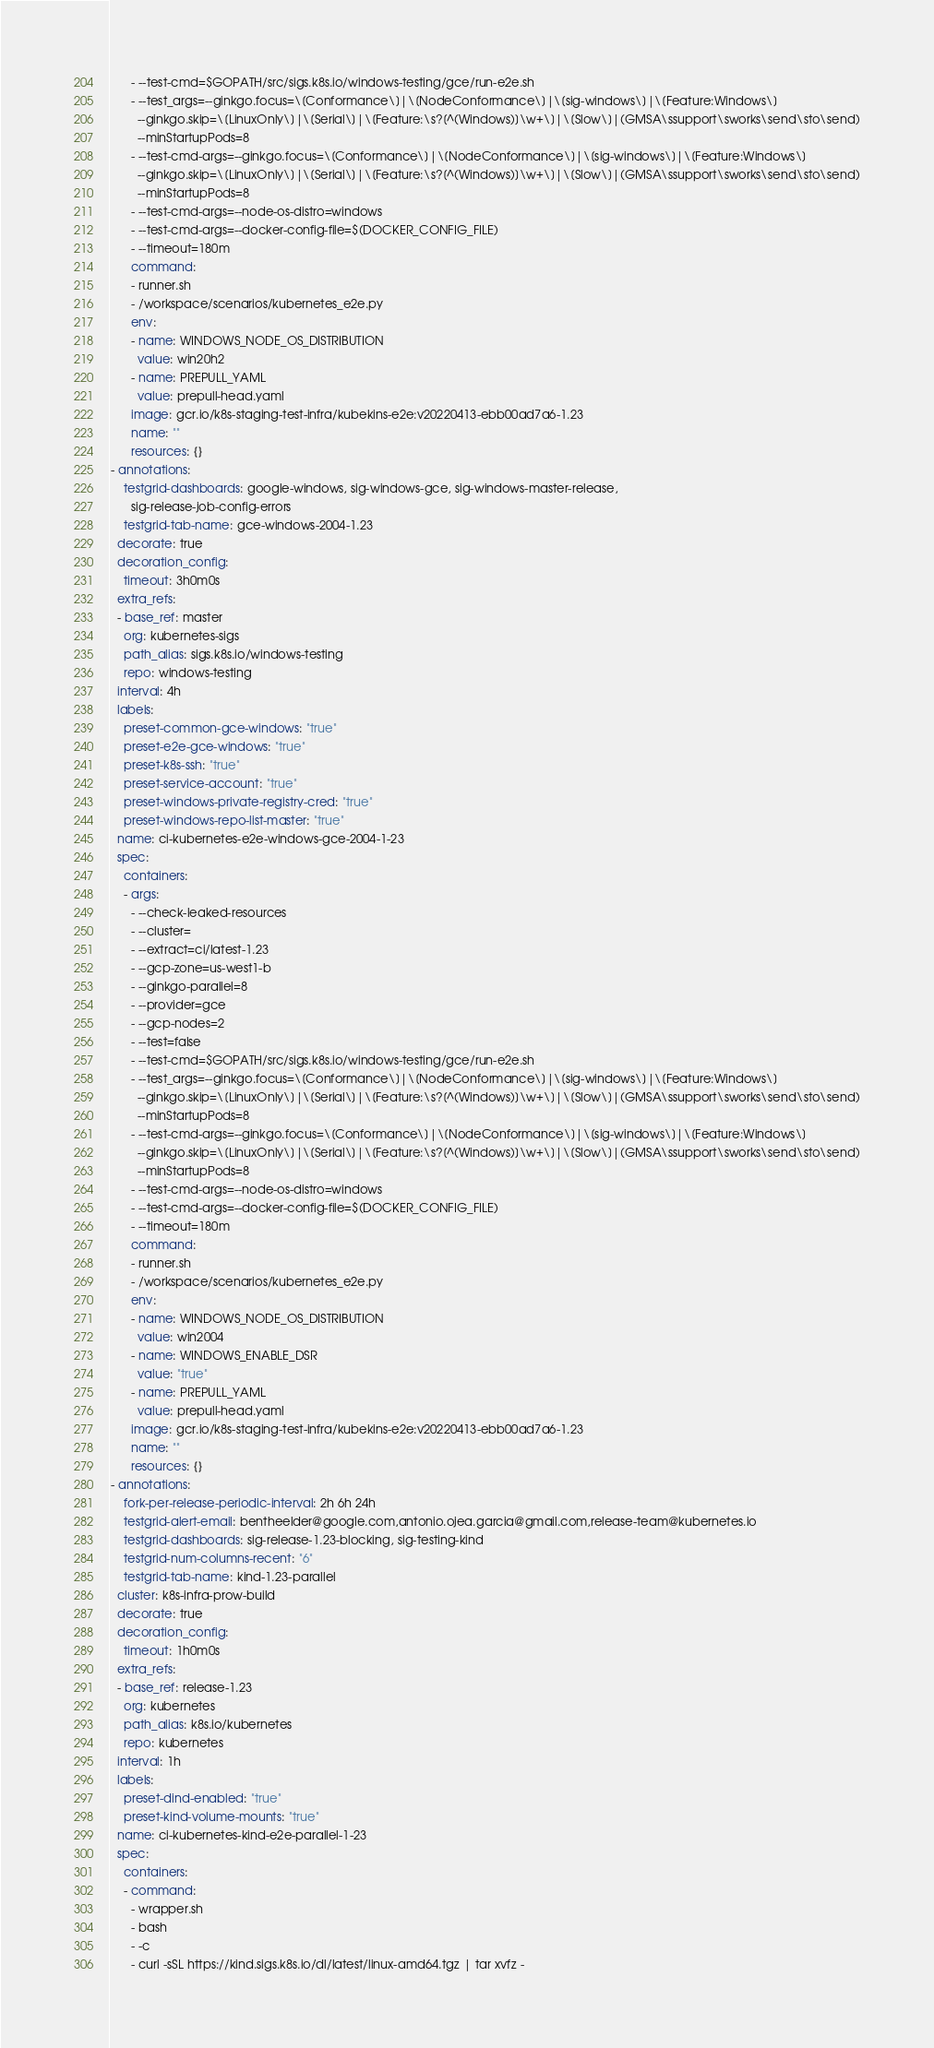Convert code to text. <code><loc_0><loc_0><loc_500><loc_500><_YAML_>      - --test-cmd=$GOPATH/src/sigs.k8s.io/windows-testing/gce/run-e2e.sh
      - --test_args=--ginkgo.focus=\[Conformance\]|\[NodeConformance\]|\[sig-windows\]|\[Feature:Windows\]
        --ginkgo.skip=\[LinuxOnly\]|\[Serial\]|\[Feature:\s?[^(Windows)]\w+\]|\[Slow\]|(GMSA\ssupport\sworks\send\sto\send)
        --minStartupPods=8
      - --test-cmd-args=--ginkgo.focus=\[Conformance\]|\[NodeConformance\]|\[sig-windows\]|\[Feature:Windows\]
        --ginkgo.skip=\[LinuxOnly\]|\[Serial\]|\[Feature:\s?[^(Windows)]\w+\]|\[Slow\]|(GMSA\ssupport\sworks\send\sto\send)
        --minStartupPods=8
      - --test-cmd-args=--node-os-distro=windows
      - --test-cmd-args=--docker-config-file=$(DOCKER_CONFIG_FILE)
      - --timeout=180m
      command:
      - runner.sh
      - /workspace/scenarios/kubernetes_e2e.py
      env:
      - name: WINDOWS_NODE_OS_DISTRIBUTION
        value: win20h2
      - name: PREPULL_YAML
        value: prepull-head.yaml
      image: gcr.io/k8s-staging-test-infra/kubekins-e2e:v20220413-ebb00ad7a6-1.23
      name: ""
      resources: {}
- annotations:
    testgrid-dashboards: google-windows, sig-windows-gce, sig-windows-master-release,
      sig-release-job-config-errors
    testgrid-tab-name: gce-windows-2004-1.23
  decorate: true
  decoration_config:
    timeout: 3h0m0s
  extra_refs:
  - base_ref: master
    org: kubernetes-sigs
    path_alias: sigs.k8s.io/windows-testing
    repo: windows-testing
  interval: 4h
  labels:
    preset-common-gce-windows: "true"
    preset-e2e-gce-windows: "true"
    preset-k8s-ssh: "true"
    preset-service-account: "true"
    preset-windows-private-registry-cred: "true"
    preset-windows-repo-list-master: "true"
  name: ci-kubernetes-e2e-windows-gce-2004-1-23
  spec:
    containers:
    - args:
      - --check-leaked-resources
      - --cluster=
      - --extract=ci/latest-1.23
      - --gcp-zone=us-west1-b
      - --ginkgo-parallel=8
      - --provider=gce
      - --gcp-nodes=2
      - --test=false
      - --test-cmd=$GOPATH/src/sigs.k8s.io/windows-testing/gce/run-e2e.sh
      - --test_args=--ginkgo.focus=\[Conformance\]|\[NodeConformance\]|\[sig-windows\]|\[Feature:Windows\]
        --ginkgo.skip=\[LinuxOnly\]|\[Serial\]|\[Feature:\s?[^(Windows)]\w+\]|\[Slow\]|(GMSA\ssupport\sworks\send\sto\send)
        --minStartupPods=8
      - --test-cmd-args=--ginkgo.focus=\[Conformance\]|\[NodeConformance\]|\[sig-windows\]|\[Feature:Windows\]
        --ginkgo.skip=\[LinuxOnly\]|\[Serial\]|\[Feature:\s?[^(Windows)]\w+\]|\[Slow\]|(GMSA\ssupport\sworks\send\sto\send)
        --minStartupPods=8
      - --test-cmd-args=--node-os-distro=windows
      - --test-cmd-args=--docker-config-file=$(DOCKER_CONFIG_FILE)
      - --timeout=180m
      command:
      - runner.sh
      - /workspace/scenarios/kubernetes_e2e.py
      env:
      - name: WINDOWS_NODE_OS_DISTRIBUTION
        value: win2004
      - name: WINDOWS_ENABLE_DSR
        value: "true"
      - name: PREPULL_YAML
        value: prepull-head.yaml
      image: gcr.io/k8s-staging-test-infra/kubekins-e2e:v20220413-ebb00ad7a6-1.23
      name: ""
      resources: {}
- annotations:
    fork-per-release-periodic-interval: 2h 6h 24h
    testgrid-alert-email: bentheelder@google.com,antonio.ojea.garcia@gmail.com,release-team@kubernetes.io
    testgrid-dashboards: sig-release-1.23-blocking, sig-testing-kind
    testgrid-num-columns-recent: "6"
    testgrid-tab-name: kind-1.23-parallel
  cluster: k8s-infra-prow-build
  decorate: true
  decoration_config:
    timeout: 1h0m0s
  extra_refs:
  - base_ref: release-1.23
    org: kubernetes
    path_alias: k8s.io/kubernetes
    repo: kubernetes
  interval: 1h
  labels:
    preset-dind-enabled: "true"
    preset-kind-volume-mounts: "true"
  name: ci-kubernetes-kind-e2e-parallel-1-23
  spec:
    containers:
    - command:
      - wrapper.sh
      - bash
      - -c
      - curl -sSL https://kind.sigs.k8s.io/dl/latest/linux-amd64.tgz | tar xvfz -</code> 